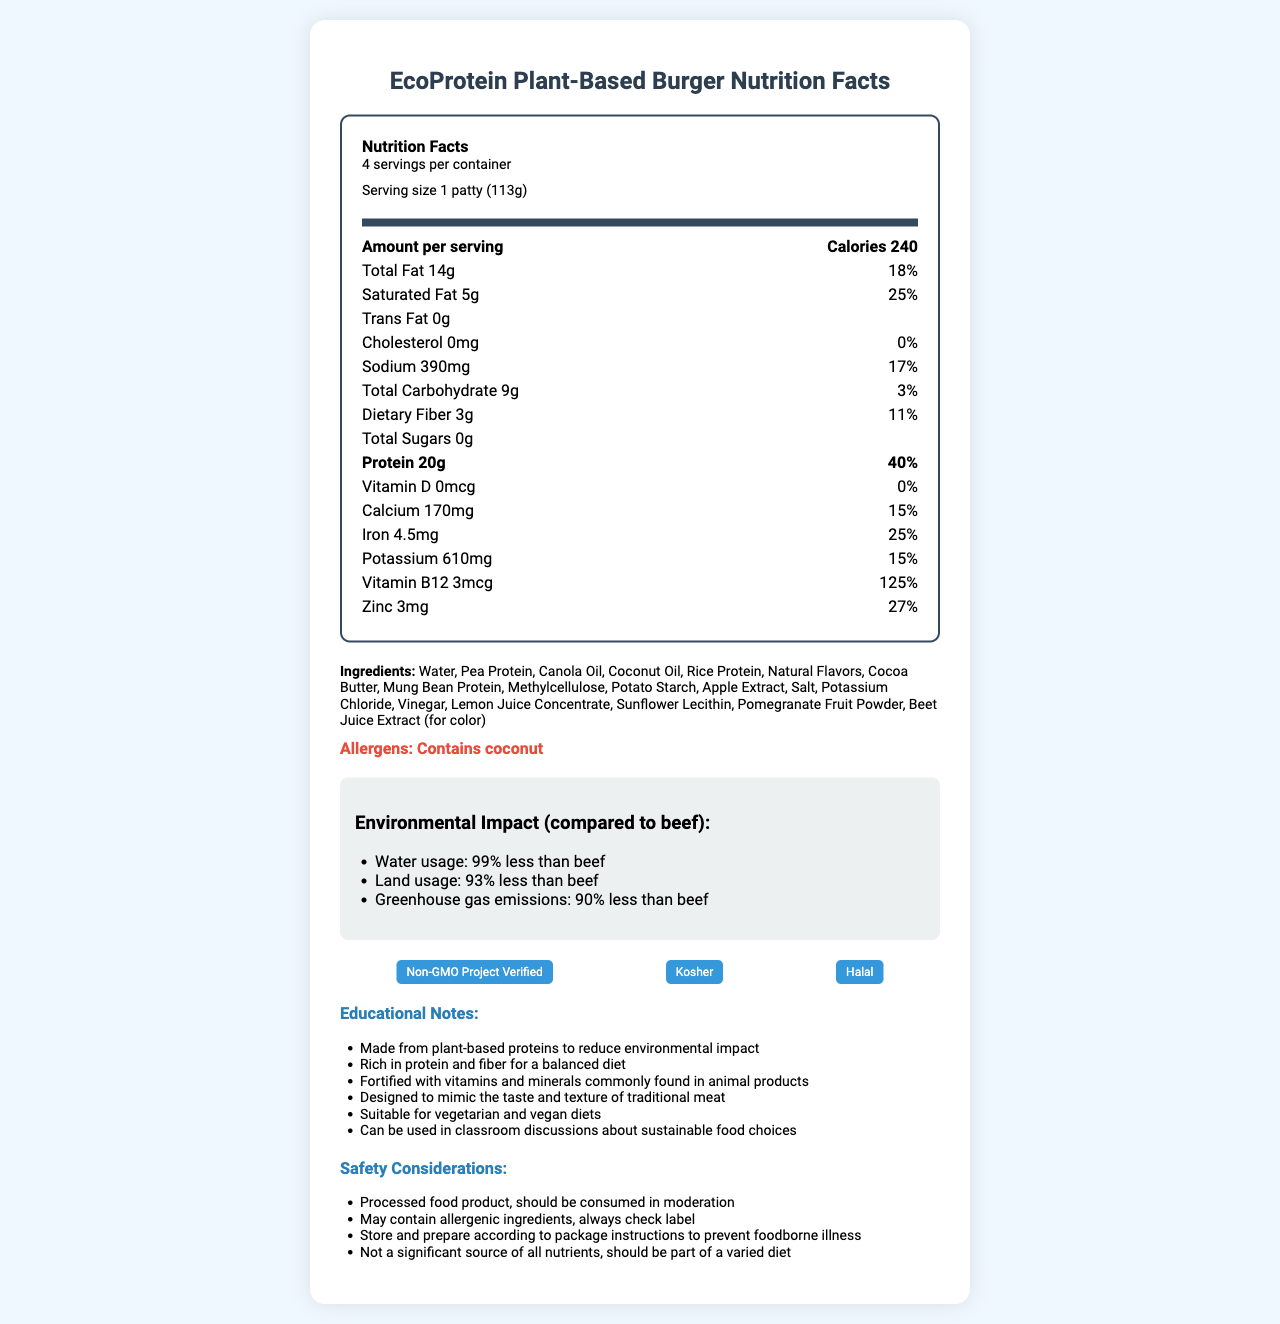what is the serving size of the EcoProtein Plant-Based Burger? The serving size is clearly mentioned as 1 patty (113g).
Answer: 1 patty (113g) how many servings are there per container? The document specifies that there are 4 servings per container.
Answer: 4 what is the total fat content per serving? The total fat content per serving is listed as 14 grams.
Answer: 14g what percentage of daily value does the sodium content represent? The daily value percentage for sodium is given as 17%.
Answer: 17% which nutrient has the highest daily value percentage? A. Protein B. Iron C. Potassium D. Vitamin B12 Vitamin B12 has the highest daily value percentage at 125%.
Answer: D how much protein is there per serving? The protein content per serving is listed as 20 grams.
Answer: 20g what are the main ingredients of the plant-based burger? The main ingredients are listed specifically in the document.
Answer: Water, Pea Protein, Canola Oil, Coconut Oil, Rice Protein, Natural Flavors, Cocoa Butter, Mung Bean Protein, Methylcellulose, Potato Starch, Apple Extract, Salt, Potassium Chloride, Vinegar, Lemon Juice Concentrate, Sunflower Lecithin, Pomegranate Fruit Powder, Beet Juice Extract (for color) does the burger contain trans fat? The trans fat content per serving is 0 grams, meaning it contains no trans fat.
Answer: No is this product suitable for vegetarian and vegan diets? The educational notes confirm that the product is suitable for vegetarian and vegan diets.
Answer: Yes describe the environmental impact of the EcoProtein Plant-Based Burger compared to beef? The document provides specific statistics that quantify the environmental impact.
Answer: The EcoProtein Plant-Based Burger uses 99% less water, 93% less land, and produces 90% less greenhouse gas emissions compared to beef. which certifications does this product have? A. Non-GMO Project Verified B. Organic C. Kosher D. Halal The product has certifications for Non-GMO Project Verified, Kosher, and Halal.
Answer: A, C, D what safety considerations should consumers be aware of? The safety considerations are outlined in a dedicated section of the document.
Answer: The product should be consumed in moderation as it is a processed food product. It may contain allergens and should be stored and prepared according to package instructions to prevent foodborne illness. It is not a significant source of all nutrients and should be part of a varied diet. what percentage of daily value does iron represent? Iron has a daily value percentage of 25%.
Answer: 25% how is the EcoProtein Plant-Based Burger fortified to resemble animal products? The educational notes mention that the product is fortified with vitamins and minerals found in animal products.
Answer: It is fortified with vitamins and minerals commonly found in animal products. how much calcium is in one serving? The amount of calcium per serving is specified as 170 milligrams.
Answer: 170mg is there any vitamin D in the EcoProtein Plant-Based Burger? The vitamin D content is listed as 0 mcg, indicating there is no vitamin D.
Answer: No can the exact preparation instructions for the patty be found in the document? The document does not provide specific preparation instructions.
Answer: Not enough information 